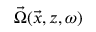<formula> <loc_0><loc_0><loc_500><loc_500>\vec { \Omega } ( \vec { x } , z , \omega )</formula> 